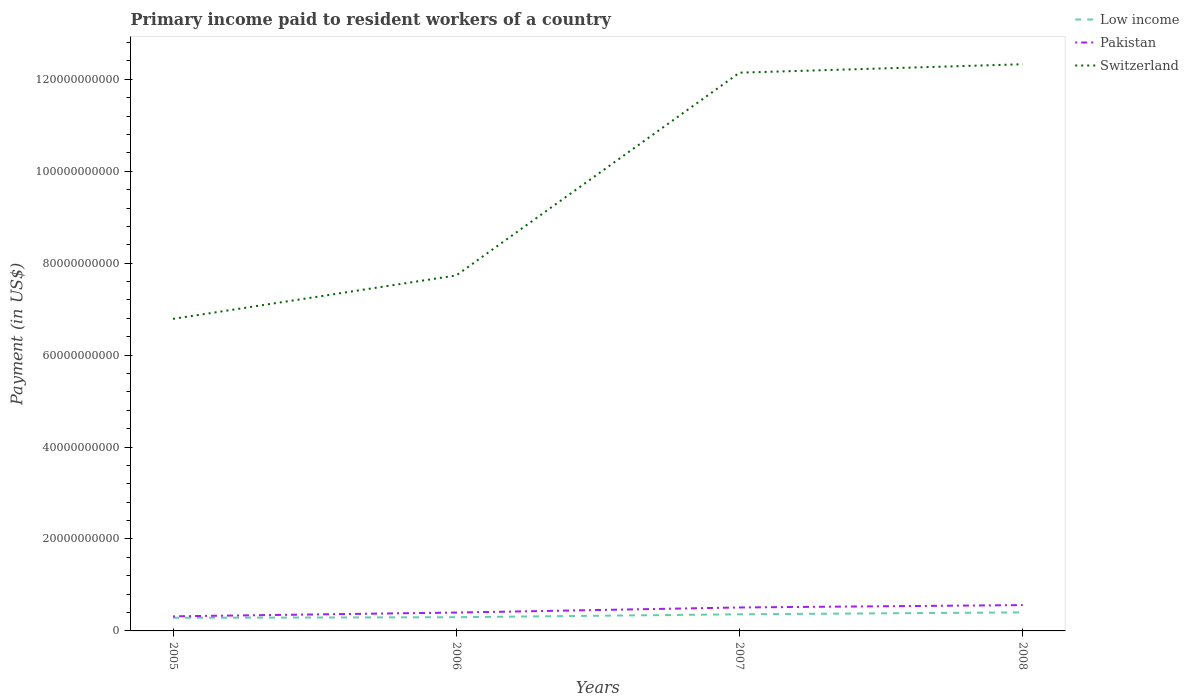Is the number of lines equal to the number of legend labels?
Your answer should be very brief. Yes. Across all years, what is the maximum amount paid to workers in Switzerland?
Offer a very short reply. 6.79e+1. In which year was the amount paid to workers in Switzerland maximum?
Offer a very short reply. 2005. What is the total amount paid to workers in Switzerland in the graph?
Provide a succinct answer. -5.36e+1. What is the difference between the highest and the second highest amount paid to workers in Switzerland?
Offer a very short reply. 5.54e+1. How many lines are there?
Provide a short and direct response. 3. How many years are there in the graph?
Ensure brevity in your answer.  4. What is the difference between two consecutive major ticks on the Y-axis?
Give a very brief answer. 2.00e+1. Does the graph contain any zero values?
Give a very brief answer. No. Where does the legend appear in the graph?
Give a very brief answer. Top right. How many legend labels are there?
Provide a succinct answer. 3. How are the legend labels stacked?
Give a very brief answer. Vertical. What is the title of the graph?
Your answer should be very brief. Primary income paid to resident workers of a country. What is the label or title of the X-axis?
Provide a succinct answer. Years. What is the label or title of the Y-axis?
Ensure brevity in your answer.  Payment (in US$). What is the Payment (in US$) in Low income in 2005?
Provide a short and direct response. 2.86e+09. What is the Payment (in US$) in Pakistan in 2005?
Make the answer very short. 3.17e+09. What is the Payment (in US$) of Switzerland in 2005?
Your response must be concise. 6.79e+1. What is the Payment (in US$) of Low income in 2006?
Ensure brevity in your answer.  2.98e+09. What is the Payment (in US$) of Pakistan in 2006?
Offer a very short reply. 4.00e+09. What is the Payment (in US$) of Switzerland in 2006?
Your answer should be compact. 7.73e+1. What is the Payment (in US$) of Low income in 2007?
Offer a very short reply. 3.62e+09. What is the Payment (in US$) of Pakistan in 2007?
Your answer should be very brief. 5.10e+09. What is the Payment (in US$) in Switzerland in 2007?
Give a very brief answer. 1.21e+11. What is the Payment (in US$) in Low income in 2008?
Your response must be concise. 4.03e+09. What is the Payment (in US$) of Pakistan in 2008?
Ensure brevity in your answer.  5.62e+09. What is the Payment (in US$) of Switzerland in 2008?
Your answer should be compact. 1.23e+11. Across all years, what is the maximum Payment (in US$) of Low income?
Offer a terse response. 4.03e+09. Across all years, what is the maximum Payment (in US$) of Pakistan?
Offer a very short reply. 5.62e+09. Across all years, what is the maximum Payment (in US$) in Switzerland?
Your answer should be compact. 1.23e+11. Across all years, what is the minimum Payment (in US$) of Low income?
Give a very brief answer. 2.86e+09. Across all years, what is the minimum Payment (in US$) of Pakistan?
Provide a succinct answer. 3.17e+09. Across all years, what is the minimum Payment (in US$) of Switzerland?
Your answer should be very brief. 6.79e+1. What is the total Payment (in US$) of Low income in the graph?
Offer a terse response. 1.35e+1. What is the total Payment (in US$) of Pakistan in the graph?
Your answer should be very brief. 1.79e+1. What is the total Payment (in US$) in Switzerland in the graph?
Make the answer very short. 3.90e+11. What is the difference between the Payment (in US$) of Low income in 2005 and that in 2006?
Give a very brief answer. -1.29e+08. What is the difference between the Payment (in US$) of Pakistan in 2005 and that in 2006?
Your answer should be very brief. -8.23e+08. What is the difference between the Payment (in US$) of Switzerland in 2005 and that in 2006?
Provide a short and direct response. -9.45e+09. What is the difference between the Payment (in US$) of Low income in 2005 and that in 2007?
Give a very brief answer. -7.63e+08. What is the difference between the Payment (in US$) of Pakistan in 2005 and that in 2007?
Offer a very short reply. -1.93e+09. What is the difference between the Payment (in US$) in Switzerland in 2005 and that in 2007?
Your answer should be compact. -5.36e+1. What is the difference between the Payment (in US$) in Low income in 2005 and that in 2008?
Keep it short and to the point. -1.18e+09. What is the difference between the Payment (in US$) in Pakistan in 2005 and that in 2008?
Your answer should be compact. -2.45e+09. What is the difference between the Payment (in US$) of Switzerland in 2005 and that in 2008?
Ensure brevity in your answer.  -5.54e+1. What is the difference between the Payment (in US$) of Low income in 2006 and that in 2007?
Provide a short and direct response. -6.34e+08. What is the difference between the Payment (in US$) of Pakistan in 2006 and that in 2007?
Give a very brief answer. -1.11e+09. What is the difference between the Payment (in US$) of Switzerland in 2006 and that in 2007?
Offer a terse response. -4.41e+1. What is the difference between the Payment (in US$) in Low income in 2006 and that in 2008?
Provide a succinct answer. -1.05e+09. What is the difference between the Payment (in US$) in Pakistan in 2006 and that in 2008?
Ensure brevity in your answer.  -1.62e+09. What is the difference between the Payment (in US$) in Switzerland in 2006 and that in 2008?
Offer a very short reply. -4.59e+1. What is the difference between the Payment (in US$) in Low income in 2007 and that in 2008?
Provide a succinct answer. -4.13e+08. What is the difference between the Payment (in US$) in Pakistan in 2007 and that in 2008?
Offer a terse response. -5.17e+08. What is the difference between the Payment (in US$) of Switzerland in 2007 and that in 2008?
Keep it short and to the point. -1.83e+09. What is the difference between the Payment (in US$) in Low income in 2005 and the Payment (in US$) in Pakistan in 2006?
Make the answer very short. -1.14e+09. What is the difference between the Payment (in US$) of Low income in 2005 and the Payment (in US$) of Switzerland in 2006?
Offer a terse response. -7.45e+1. What is the difference between the Payment (in US$) of Pakistan in 2005 and the Payment (in US$) of Switzerland in 2006?
Provide a succinct answer. -7.42e+1. What is the difference between the Payment (in US$) in Low income in 2005 and the Payment (in US$) in Pakistan in 2007?
Offer a terse response. -2.25e+09. What is the difference between the Payment (in US$) in Low income in 2005 and the Payment (in US$) in Switzerland in 2007?
Provide a short and direct response. -1.19e+11. What is the difference between the Payment (in US$) in Pakistan in 2005 and the Payment (in US$) in Switzerland in 2007?
Your answer should be compact. -1.18e+11. What is the difference between the Payment (in US$) in Low income in 2005 and the Payment (in US$) in Pakistan in 2008?
Keep it short and to the point. -2.76e+09. What is the difference between the Payment (in US$) of Low income in 2005 and the Payment (in US$) of Switzerland in 2008?
Provide a succinct answer. -1.20e+11. What is the difference between the Payment (in US$) in Pakistan in 2005 and the Payment (in US$) in Switzerland in 2008?
Keep it short and to the point. -1.20e+11. What is the difference between the Payment (in US$) of Low income in 2006 and the Payment (in US$) of Pakistan in 2007?
Your answer should be compact. -2.12e+09. What is the difference between the Payment (in US$) of Low income in 2006 and the Payment (in US$) of Switzerland in 2007?
Your response must be concise. -1.18e+11. What is the difference between the Payment (in US$) of Pakistan in 2006 and the Payment (in US$) of Switzerland in 2007?
Give a very brief answer. -1.17e+11. What is the difference between the Payment (in US$) in Low income in 2006 and the Payment (in US$) in Pakistan in 2008?
Offer a terse response. -2.63e+09. What is the difference between the Payment (in US$) in Low income in 2006 and the Payment (in US$) in Switzerland in 2008?
Give a very brief answer. -1.20e+11. What is the difference between the Payment (in US$) in Pakistan in 2006 and the Payment (in US$) in Switzerland in 2008?
Give a very brief answer. -1.19e+11. What is the difference between the Payment (in US$) of Low income in 2007 and the Payment (in US$) of Pakistan in 2008?
Provide a succinct answer. -2.00e+09. What is the difference between the Payment (in US$) in Low income in 2007 and the Payment (in US$) in Switzerland in 2008?
Keep it short and to the point. -1.20e+11. What is the difference between the Payment (in US$) of Pakistan in 2007 and the Payment (in US$) of Switzerland in 2008?
Offer a terse response. -1.18e+11. What is the average Payment (in US$) in Low income per year?
Provide a short and direct response. 3.37e+09. What is the average Payment (in US$) of Pakistan per year?
Your answer should be very brief. 4.47e+09. What is the average Payment (in US$) in Switzerland per year?
Your response must be concise. 9.75e+1. In the year 2005, what is the difference between the Payment (in US$) in Low income and Payment (in US$) in Pakistan?
Offer a very short reply. -3.17e+08. In the year 2005, what is the difference between the Payment (in US$) in Low income and Payment (in US$) in Switzerland?
Your answer should be compact. -6.50e+1. In the year 2005, what is the difference between the Payment (in US$) in Pakistan and Payment (in US$) in Switzerland?
Your answer should be compact. -6.47e+1. In the year 2006, what is the difference between the Payment (in US$) in Low income and Payment (in US$) in Pakistan?
Your answer should be compact. -1.01e+09. In the year 2006, what is the difference between the Payment (in US$) in Low income and Payment (in US$) in Switzerland?
Offer a terse response. -7.43e+1. In the year 2006, what is the difference between the Payment (in US$) of Pakistan and Payment (in US$) of Switzerland?
Offer a terse response. -7.33e+1. In the year 2007, what is the difference between the Payment (in US$) in Low income and Payment (in US$) in Pakistan?
Ensure brevity in your answer.  -1.48e+09. In the year 2007, what is the difference between the Payment (in US$) of Low income and Payment (in US$) of Switzerland?
Your answer should be compact. -1.18e+11. In the year 2007, what is the difference between the Payment (in US$) in Pakistan and Payment (in US$) in Switzerland?
Give a very brief answer. -1.16e+11. In the year 2008, what is the difference between the Payment (in US$) of Low income and Payment (in US$) of Pakistan?
Your response must be concise. -1.59e+09. In the year 2008, what is the difference between the Payment (in US$) in Low income and Payment (in US$) in Switzerland?
Your response must be concise. -1.19e+11. In the year 2008, what is the difference between the Payment (in US$) in Pakistan and Payment (in US$) in Switzerland?
Offer a very short reply. -1.18e+11. What is the ratio of the Payment (in US$) of Low income in 2005 to that in 2006?
Your response must be concise. 0.96. What is the ratio of the Payment (in US$) of Pakistan in 2005 to that in 2006?
Give a very brief answer. 0.79. What is the ratio of the Payment (in US$) in Switzerland in 2005 to that in 2006?
Your response must be concise. 0.88. What is the ratio of the Payment (in US$) of Low income in 2005 to that in 2007?
Provide a short and direct response. 0.79. What is the ratio of the Payment (in US$) in Pakistan in 2005 to that in 2007?
Your answer should be compact. 0.62. What is the ratio of the Payment (in US$) in Switzerland in 2005 to that in 2007?
Your answer should be very brief. 0.56. What is the ratio of the Payment (in US$) in Low income in 2005 to that in 2008?
Offer a terse response. 0.71. What is the ratio of the Payment (in US$) of Pakistan in 2005 to that in 2008?
Your answer should be compact. 0.56. What is the ratio of the Payment (in US$) in Switzerland in 2005 to that in 2008?
Provide a short and direct response. 0.55. What is the ratio of the Payment (in US$) in Low income in 2006 to that in 2007?
Offer a very short reply. 0.82. What is the ratio of the Payment (in US$) in Pakistan in 2006 to that in 2007?
Provide a succinct answer. 0.78. What is the ratio of the Payment (in US$) of Switzerland in 2006 to that in 2007?
Your answer should be very brief. 0.64. What is the ratio of the Payment (in US$) of Low income in 2006 to that in 2008?
Provide a short and direct response. 0.74. What is the ratio of the Payment (in US$) of Pakistan in 2006 to that in 2008?
Give a very brief answer. 0.71. What is the ratio of the Payment (in US$) of Switzerland in 2006 to that in 2008?
Your response must be concise. 0.63. What is the ratio of the Payment (in US$) of Low income in 2007 to that in 2008?
Give a very brief answer. 0.9. What is the ratio of the Payment (in US$) in Pakistan in 2007 to that in 2008?
Make the answer very short. 0.91. What is the ratio of the Payment (in US$) of Switzerland in 2007 to that in 2008?
Provide a short and direct response. 0.99. What is the difference between the highest and the second highest Payment (in US$) of Low income?
Make the answer very short. 4.13e+08. What is the difference between the highest and the second highest Payment (in US$) in Pakistan?
Your answer should be compact. 5.17e+08. What is the difference between the highest and the second highest Payment (in US$) of Switzerland?
Provide a short and direct response. 1.83e+09. What is the difference between the highest and the lowest Payment (in US$) of Low income?
Provide a succinct answer. 1.18e+09. What is the difference between the highest and the lowest Payment (in US$) in Pakistan?
Your answer should be very brief. 2.45e+09. What is the difference between the highest and the lowest Payment (in US$) of Switzerland?
Offer a very short reply. 5.54e+1. 